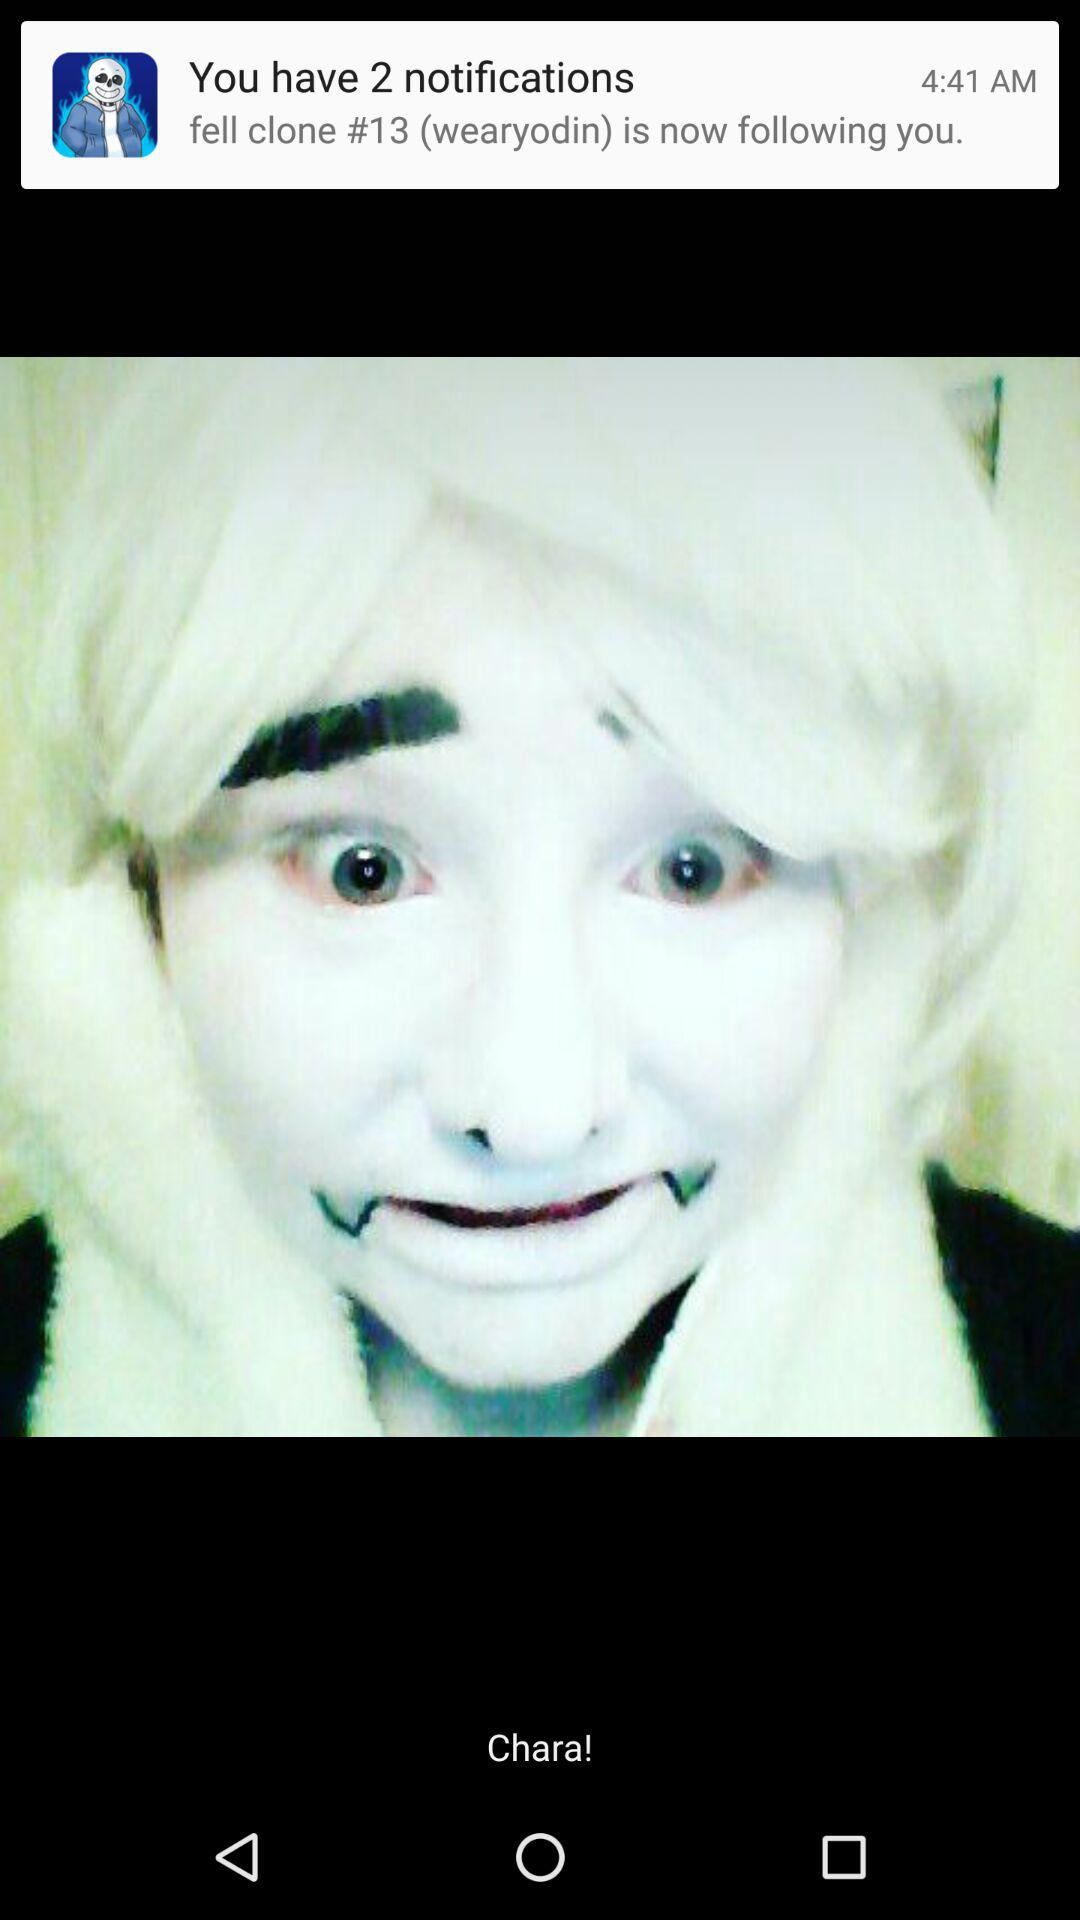What is the number of new notifications? The number of new notifications is 2. 